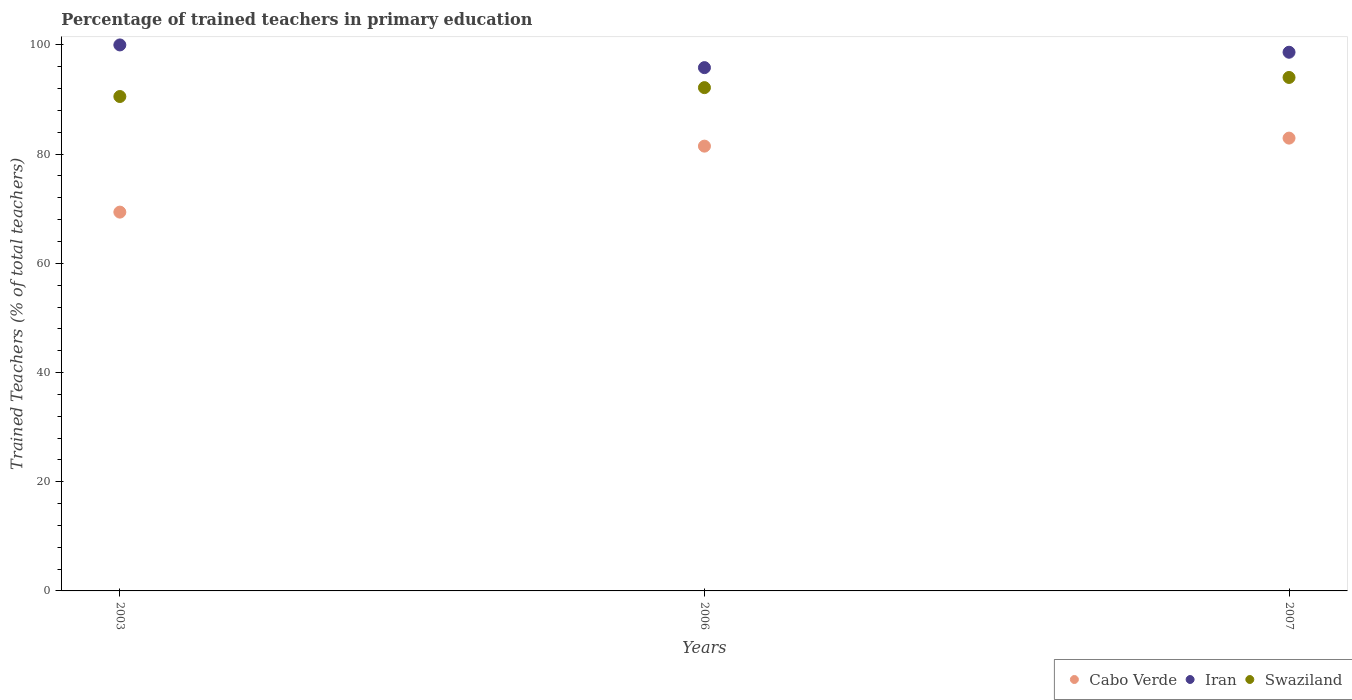How many different coloured dotlines are there?
Ensure brevity in your answer.  3. What is the percentage of trained teachers in Cabo Verde in 2007?
Give a very brief answer. 82.93. Across all years, what is the maximum percentage of trained teachers in Cabo Verde?
Offer a terse response. 82.93. Across all years, what is the minimum percentage of trained teachers in Iran?
Offer a terse response. 95.84. In which year was the percentage of trained teachers in Cabo Verde minimum?
Give a very brief answer. 2003. What is the total percentage of trained teachers in Iran in the graph?
Provide a short and direct response. 294.5. What is the difference between the percentage of trained teachers in Swaziland in 2003 and that in 2006?
Ensure brevity in your answer.  -1.63. What is the difference between the percentage of trained teachers in Cabo Verde in 2006 and the percentage of trained teachers in Iran in 2007?
Keep it short and to the point. -17.2. What is the average percentage of trained teachers in Cabo Verde per year?
Provide a short and direct response. 77.93. In the year 2006, what is the difference between the percentage of trained teachers in Cabo Verde and percentage of trained teachers in Swaziland?
Ensure brevity in your answer.  -10.72. In how many years, is the percentage of trained teachers in Cabo Verde greater than 36 %?
Provide a short and direct response. 3. What is the ratio of the percentage of trained teachers in Swaziland in 2003 to that in 2007?
Your response must be concise. 0.96. Is the percentage of trained teachers in Iran in 2006 less than that in 2007?
Provide a succinct answer. Yes. What is the difference between the highest and the second highest percentage of trained teachers in Cabo Verde?
Provide a succinct answer. 1.47. What is the difference between the highest and the lowest percentage of trained teachers in Iran?
Ensure brevity in your answer.  4.16. How many dotlines are there?
Offer a terse response. 3. How many years are there in the graph?
Offer a very short reply. 3. Are the values on the major ticks of Y-axis written in scientific E-notation?
Give a very brief answer. No. Does the graph contain any zero values?
Your answer should be compact. No. Does the graph contain grids?
Offer a very short reply. No. Where does the legend appear in the graph?
Make the answer very short. Bottom right. How many legend labels are there?
Offer a terse response. 3. How are the legend labels stacked?
Provide a short and direct response. Horizontal. What is the title of the graph?
Provide a succinct answer. Percentage of trained teachers in primary education. Does "Portugal" appear as one of the legend labels in the graph?
Provide a succinct answer. No. What is the label or title of the X-axis?
Your answer should be compact. Years. What is the label or title of the Y-axis?
Ensure brevity in your answer.  Trained Teachers (% of total teachers). What is the Trained Teachers (% of total teachers) of Cabo Verde in 2003?
Offer a terse response. 69.38. What is the Trained Teachers (% of total teachers) of Iran in 2003?
Your response must be concise. 100. What is the Trained Teachers (% of total teachers) in Swaziland in 2003?
Make the answer very short. 90.55. What is the Trained Teachers (% of total teachers) of Cabo Verde in 2006?
Keep it short and to the point. 81.46. What is the Trained Teachers (% of total teachers) in Iran in 2006?
Make the answer very short. 95.84. What is the Trained Teachers (% of total teachers) in Swaziland in 2006?
Your response must be concise. 92.18. What is the Trained Teachers (% of total teachers) of Cabo Verde in 2007?
Provide a succinct answer. 82.93. What is the Trained Teachers (% of total teachers) of Iran in 2007?
Offer a very short reply. 98.66. What is the Trained Teachers (% of total teachers) of Swaziland in 2007?
Give a very brief answer. 94.04. Across all years, what is the maximum Trained Teachers (% of total teachers) in Cabo Verde?
Your answer should be compact. 82.93. Across all years, what is the maximum Trained Teachers (% of total teachers) in Swaziland?
Offer a very short reply. 94.04. Across all years, what is the minimum Trained Teachers (% of total teachers) of Cabo Verde?
Your answer should be compact. 69.38. Across all years, what is the minimum Trained Teachers (% of total teachers) in Iran?
Offer a terse response. 95.84. Across all years, what is the minimum Trained Teachers (% of total teachers) in Swaziland?
Your response must be concise. 90.55. What is the total Trained Teachers (% of total teachers) of Cabo Verde in the graph?
Your answer should be compact. 233.78. What is the total Trained Teachers (% of total teachers) in Iran in the graph?
Provide a short and direct response. 294.5. What is the total Trained Teachers (% of total teachers) in Swaziland in the graph?
Give a very brief answer. 276.78. What is the difference between the Trained Teachers (% of total teachers) of Cabo Verde in 2003 and that in 2006?
Your answer should be compact. -12.08. What is the difference between the Trained Teachers (% of total teachers) of Iran in 2003 and that in 2006?
Your response must be concise. 4.16. What is the difference between the Trained Teachers (% of total teachers) in Swaziland in 2003 and that in 2006?
Your response must be concise. -1.63. What is the difference between the Trained Teachers (% of total teachers) of Cabo Verde in 2003 and that in 2007?
Give a very brief answer. -13.55. What is the difference between the Trained Teachers (% of total teachers) in Iran in 2003 and that in 2007?
Provide a short and direct response. 1.34. What is the difference between the Trained Teachers (% of total teachers) in Swaziland in 2003 and that in 2007?
Make the answer very short. -3.49. What is the difference between the Trained Teachers (% of total teachers) in Cabo Verde in 2006 and that in 2007?
Your answer should be very brief. -1.47. What is the difference between the Trained Teachers (% of total teachers) in Iran in 2006 and that in 2007?
Provide a succinct answer. -2.82. What is the difference between the Trained Teachers (% of total teachers) in Swaziland in 2006 and that in 2007?
Offer a very short reply. -1.86. What is the difference between the Trained Teachers (% of total teachers) of Cabo Verde in 2003 and the Trained Teachers (% of total teachers) of Iran in 2006?
Ensure brevity in your answer.  -26.46. What is the difference between the Trained Teachers (% of total teachers) of Cabo Verde in 2003 and the Trained Teachers (% of total teachers) of Swaziland in 2006?
Give a very brief answer. -22.8. What is the difference between the Trained Teachers (% of total teachers) in Iran in 2003 and the Trained Teachers (% of total teachers) in Swaziland in 2006?
Offer a terse response. 7.82. What is the difference between the Trained Teachers (% of total teachers) in Cabo Verde in 2003 and the Trained Teachers (% of total teachers) in Iran in 2007?
Your answer should be very brief. -29.28. What is the difference between the Trained Teachers (% of total teachers) of Cabo Verde in 2003 and the Trained Teachers (% of total teachers) of Swaziland in 2007?
Provide a succinct answer. -24.66. What is the difference between the Trained Teachers (% of total teachers) in Iran in 2003 and the Trained Teachers (% of total teachers) in Swaziland in 2007?
Your answer should be very brief. 5.96. What is the difference between the Trained Teachers (% of total teachers) in Cabo Verde in 2006 and the Trained Teachers (% of total teachers) in Iran in 2007?
Make the answer very short. -17.2. What is the difference between the Trained Teachers (% of total teachers) in Cabo Verde in 2006 and the Trained Teachers (% of total teachers) in Swaziland in 2007?
Make the answer very short. -12.58. What is the difference between the Trained Teachers (% of total teachers) in Iran in 2006 and the Trained Teachers (% of total teachers) in Swaziland in 2007?
Make the answer very short. 1.8. What is the average Trained Teachers (% of total teachers) of Cabo Verde per year?
Your response must be concise. 77.93. What is the average Trained Teachers (% of total teachers) in Iran per year?
Give a very brief answer. 98.17. What is the average Trained Teachers (% of total teachers) of Swaziland per year?
Make the answer very short. 92.26. In the year 2003, what is the difference between the Trained Teachers (% of total teachers) of Cabo Verde and Trained Teachers (% of total teachers) of Iran?
Your response must be concise. -30.62. In the year 2003, what is the difference between the Trained Teachers (% of total teachers) of Cabo Verde and Trained Teachers (% of total teachers) of Swaziland?
Provide a succinct answer. -21.17. In the year 2003, what is the difference between the Trained Teachers (% of total teachers) of Iran and Trained Teachers (% of total teachers) of Swaziland?
Your answer should be very brief. 9.45. In the year 2006, what is the difference between the Trained Teachers (% of total teachers) of Cabo Verde and Trained Teachers (% of total teachers) of Iran?
Your answer should be compact. -14.38. In the year 2006, what is the difference between the Trained Teachers (% of total teachers) of Cabo Verde and Trained Teachers (% of total teachers) of Swaziland?
Your response must be concise. -10.72. In the year 2006, what is the difference between the Trained Teachers (% of total teachers) in Iran and Trained Teachers (% of total teachers) in Swaziland?
Ensure brevity in your answer.  3.66. In the year 2007, what is the difference between the Trained Teachers (% of total teachers) of Cabo Verde and Trained Teachers (% of total teachers) of Iran?
Ensure brevity in your answer.  -15.73. In the year 2007, what is the difference between the Trained Teachers (% of total teachers) in Cabo Verde and Trained Teachers (% of total teachers) in Swaziland?
Offer a terse response. -11.11. In the year 2007, what is the difference between the Trained Teachers (% of total teachers) of Iran and Trained Teachers (% of total teachers) of Swaziland?
Your answer should be very brief. 4.62. What is the ratio of the Trained Teachers (% of total teachers) of Cabo Verde in 2003 to that in 2006?
Offer a very short reply. 0.85. What is the ratio of the Trained Teachers (% of total teachers) in Iran in 2003 to that in 2006?
Keep it short and to the point. 1.04. What is the ratio of the Trained Teachers (% of total teachers) in Swaziland in 2003 to that in 2006?
Make the answer very short. 0.98. What is the ratio of the Trained Teachers (% of total teachers) in Cabo Verde in 2003 to that in 2007?
Make the answer very short. 0.84. What is the ratio of the Trained Teachers (% of total teachers) of Iran in 2003 to that in 2007?
Provide a succinct answer. 1.01. What is the ratio of the Trained Teachers (% of total teachers) of Swaziland in 2003 to that in 2007?
Offer a very short reply. 0.96. What is the ratio of the Trained Teachers (% of total teachers) of Cabo Verde in 2006 to that in 2007?
Your response must be concise. 0.98. What is the ratio of the Trained Teachers (% of total teachers) of Iran in 2006 to that in 2007?
Give a very brief answer. 0.97. What is the ratio of the Trained Teachers (% of total teachers) in Swaziland in 2006 to that in 2007?
Your answer should be compact. 0.98. What is the difference between the highest and the second highest Trained Teachers (% of total teachers) in Cabo Verde?
Keep it short and to the point. 1.47. What is the difference between the highest and the second highest Trained Teachers (% of total teachers) in Iran?
Your answer should be compact. 1.34. What is the difference between the highest and the second highest Trained Teachers (% of total teachers) in Swaziland?
Ensure brevity in your answer.  1.86. What is the difference between the highest and the lowest Trained Teachers (% of total teachers) of Cabo Verde?
Give a very brief answer. 13.55. What is the difference between the highest and the lowest Trained Teachers (% of total teachers) of Iran?
Offer a terse response. 4.16. What is the difference between the highest and the lowest Trained Teachers (% of total teachers) in Swaziland?
Your answer should be very brief. 3.49. 